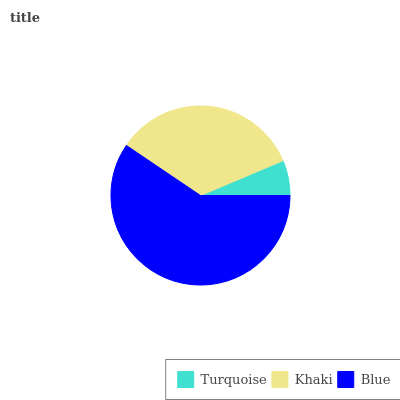Is Turquoise the minimum?
Answer yes or no. Yes. Is Blue the maximum?
Answer yes or no. Yes. Is Khaki the minimum?
Answer yes or no. No. Is Khaki the maximum?
Answer yes or no. No. Is Khaki greater than Turquoise?
Answer yes or no. Yes. Is Turquoise less than Khaki?
Answer yes or no. Yes. Is Turquoise greater than Khaki?
Answer yes or no. No. Is Khaki less than Turquoise?
Answer yes or no. No. Is Khaki the high median?
Answer yes or no. Yes. Is Khaki the low median?
Answer yes or no. Yes. Is Turquoise the high median?
Answer yes or no. No. Is Blue the low median?
Answer yes or no. No. 